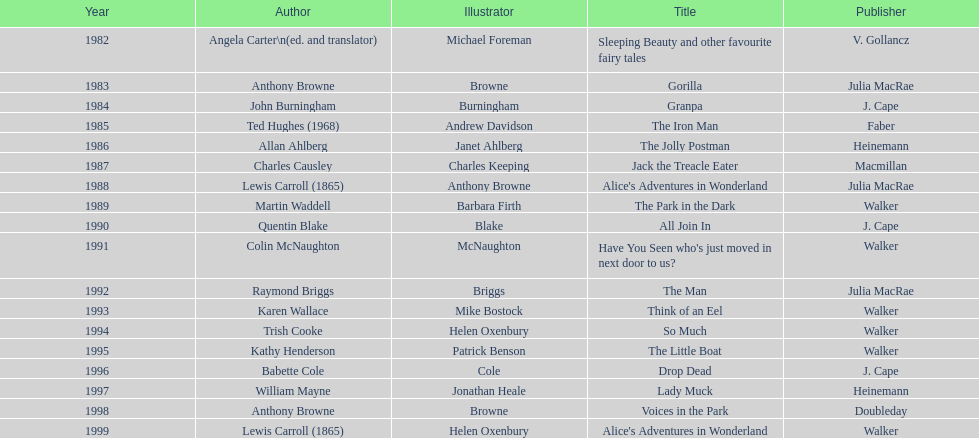How many titles did walker publish? 6. 